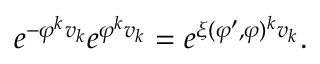Convert formula to latex. <formula><loc_0><loc_0><loc_500><loc_500>e ^ { - \varphi ^ { k } v _ { k } } e ^ { \varphi ^ { k } v _ { k } } = e ^ { \xi ( \varphi ^ { \prime } , \varphi ) ^ { k } v _ { k } } .</formula> 